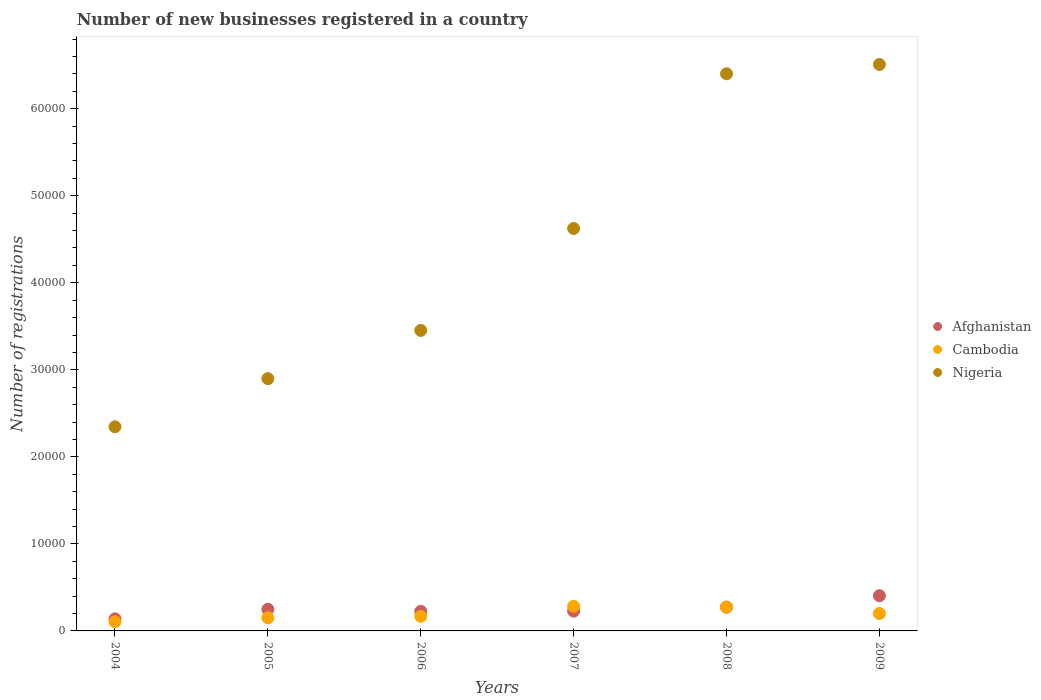What is the number of new businesses registered in Cambodia in 2004?
Your answer should be very brief. 1049. Across all years, what is the maximum number of new businesses registered in Nigeria?
Provide a succinct answer. 6.51e+04. Across all years, what is the minimum number of new businesses registered in Cambodia?
Offer a terse response. 1049. In which year was the number of new businesses registered in Nigeria maximum?
Your answer should be very brief. 2009. In which year was the number of new businesses registered in Afghanistan minimum?
Your response must be concise. 2004. What is the total number of new businesses registered in Cambodia in the graph?
Your answer should be very brief. 1.18e+04. What is the difference between the number of new businesses registered in Nigeria in 2004 and that in 2006?
Keep it short and to the point. -1.11e+04. What is the difference between the number of new businesses registered in Cambodia in 2006 and the number of new businesses registered in Afghanistan in 2007?
Your answer should be very brief. -606. What is the average number of new businesses registered in Afghanistan per year?
Provide a succinct answer. 2527.5. In the year 2004, what is the difference between the number of new businesses registered in Nigeria and number of new businesses registered in Afghanistan?
Offer a terse response. 2.21e+04. In how many years, is the number of new businesses registered in Nigeria greater than 28000?
Your answer should be very brief. 5. What is the ratio of the number of new businesses registered in Cambodia in 2006 to that in 2009?
Your answer should be very brief. 0.83. Is the number of new businesses registered in Afghanistan in 2007 less than that in 2009?
Your response must be concise. Yes. Is the difference between the number of new businesses registered in Nigeria in 2004 and 2008 greater than the difference between the number of new businesses registered in Afghanistan in 2004 and 2008?
Keep it short and to the point. No. What is the difference between the highest and the second highest number of new businesses registered in Nigeria?
Provide a short and direct response. 1072. What is the difference between the highest and the lowest number of new businesses registered in Afghanistan?
Keep it short and to the point. 2655. Does the number of new businesses registered in Afghanistan monotonically increase over the years?
Make the answer very short. No. Is the number of new businesses registered in Afghanistan strictly greater than the number of new businesses registered in Cambodia over the years?
Your answer should be very brief. No. How many dotlines are there?
Ensure brevity in your answer.  3. Are the values on the major ticks of Y-axis written in scientific E-notation?
Keep it short and to the point. No. Does the graph contain any zero values?
Your answer should be compact. No. Where does the legend appear in the graph?
Provide a succinct answer. Center right. How are the legend labels stacked?
Provide a succinct answer. Vertical. What is the title of the graph?
Offer a very short reply. Number of new businesses registered in a country. What is the label or title of the Y-axis?
Keep it short and to the point. Number of registrations. What is the Number of registrations of Afghanistan in 2004?
Provide a succinct answer. 1388. What is the Number of registrations of Cambodia in 2004?
Offer a terse response. 1049. What is the Number of registrations in Nigeria in 2004?
Your answer should be very brief. 2.35e+04. What is the Number of registrations in Afghanistan in 2005?
Give a very brief answer. 2486. What is the Number of registrations of Cambodia in 2005?
Ensure brevity in your answer.  1509. What is the Number of registrations in Nigeria in 2005?
Ensure brevity in your answer.  2.90e+04. What is the Number of registrations of Afghanistan in 2006?
Offer a terse response. 2252. What is the Number of registrations in Cambodia in 2006?
Provide a short and direct response. 1670. What is the Number of registrations of Nigeria in 2006?
Your answer should be very brief. 3.45e+04. What is the Number of registrations in Afghanistan in 2007?
Provide a short and direct response. 2276. What is the Number of registrations of Cambodia in 2007?
Provide a succinct answer. 2826. What is the Number of registrations of Nigeria in 2007?
Ensure brevity in your answer.  4.62e+04. What is the Number of registrations in Afghanistan in 2008?
Make the answer very short. 2720. What is the Number of registrations of Cambodia in 2008?
Offer a terse response. 2744. What is the Number of registrations of Nigeria in 2008?
Your answer should be compact. 6.40e+04. What is the Number of registrations of Afghanistan in 2009?
Offer a very short reply. 4043. What is the Number of registrations in Cambodia in 2009?
Make the answer very short. 2003. What is the Number of registrations in Nigeria in 2009?
Provide a succinct answer. 6.51e+04. Across all years, what is the maximum Number of registrations of Afghanistan?
Give a very brief answer. 4043. Across all years, what is the maximum Number of registrations of Cambodia?
Your response must be concise. 2826. Across all years, what is the maximum Number of registrations of Nigeria?
Provide a succinct answer. 6.51e+04. Across all years, what is the minimum Number of registrations in Afghanistan?
Ensure brevity in your answer.  1388. Across all years, what is the minimum Number of registrations of Cambodia?
Offer a terse response. 1049. Across all years, what is the minimum Number of registrations in Nigeria?
Give a very brief answer. 2.35e+04. What is the total Number of registrations of Afghanistan in the graph?
Your answer should be very brief. 1.52e+04. What is the total Number of registrations of Cambodia in the graph?
Keep it short and to the point. 1.18e+04. What is the total Number of registrations of Nigeria in the graph?
Offer a very short reply. 2.62e+05. What is the difference between the Number of registrations in Afghanistan in 2004 and that in 2005?
Give a very brief answer. -1098. What is the difference between the Number of registrations in Cambodia in 2004 and that in 2005?
Your answer should be compact. -460. What is the difference between the Number of registrations in Nigeria in 2004 and that in 2005?
Your answer should be compact. -5531. What is the difference between the Number of registrations of Afghanistan in 2004 and that in 2006?
Your answer should be compact. -864. What is the difference between the Number of registrations in Cambodia in 2004 and that in 2006?
Offer a terse response. -621. What is the difference between the Number of registrations in Nigeria in 2004 and that in 2006?
Offer a very short reply. -1.11e+04. What is the difference between the Number of registrations of Afghanistan in 2004 and that in 2007?
Keep it short and to the point. -888. What is the difference between the Number of registrations of Cambodia in 2004 and that in 2007?
Give a very brief answer. -1777. What is the difference between the Number of registrations of Nigeria in 2004 and that in 2007?
Offer a terse response. -2.28e+04. What is the difference between the Number of registrations of Afghanistan in 2004 and that in 2008?
Provide a succinct answer. -1332. What is the difference between the Number of registrations in Cambodia in 2004 and that in 2008?
Offer a terse response. -1695. What is the difference between the Number of registrations of Nigeria in 2004 and that in 2008?
Make the answer very short. -4.06e+04. What is the difference between the Number of registrations in Afghanistan in 2004 and that in 2009?
Ensure brevity in your answer.  -2655. What is the difference between the Number of registrations in Cambodia in 2004 and that in 2009?
Your response must be concise. -954. What is the difference between the Number of registrations of Nigeria in 2004 and that in 2009?
Offer a terse response. -4.16e+04. What is the difference between the Number of registrations in Afghanistan in 2005 and that in 2006?
Provide a short and direct response. 234. What is the difference between the Number of registrations in Cambodia in 2005 and that in 2006?
Keep it short and to the point. -161. What is the difference between the Number of registrations in Nigeria in 2005 and that in 2006?
Offer a terse response. -5543. What is the difference between the Number of registrations in Afghanistan in 2005 and that in 2007?
Give a very brief answer. 210. What is the difference between the Number of registrations of Cambodia in 2005 and that in 2007?
Provide a succinct answer. -1317. What is the difference between the Number of registrations in Nigeria in 2005 and that in 2007?
Your answer should be compact. -1.73e+04. What is the difference between the Number of registrations of Afghanistan in 2005 and that in 2008?
Your answer should be very brief. -234. What is the difference between the Number of registrations in Cambodia in 2005 and that in 2008?
Your answer should be very brief. -1235. What is the difference between the Number of registrations in Nigeria in 2005 and that in 2008?
Make the answer very short. -3.50e+04. What is the difference between the Number of registrations of Afghanistan in 2005 and that in 2009?
Offer a terse response. -1557. What is the difference between the Number of registrations in Cambodia in 2005 and that in 2009?
Offer a very short reply. -494. What is the difference between the Number of registrations in Nigeria in 2005 and that in 2009?
Give a very brief answer. -3.61e+04. What is the difference between the Number of registrations in Cambodia in 2006 and that in 2007?
Ensure brevity in your answer.  -1156. What is the difference between the Number of registrations of Nigeria in 2006 and that in 2007?
Make the answer very short. -1.17e+04. What is the difference between the Number of registrations in Afghanistan in 2006 and that in 2008?
Ensure brevity in your answer.  -468. What is the difference between the Number of registrations in Cambodia in 2006 and that in 2008?
Your answer should be very brief. -1074. What is the difference between the Number of registrations in Nigeria in 2006 and that in 2008?
Your answer should be very brief. -2.95e+04. What is the difference between the Number of registrations of Afghanistan in 2006 and that in 2009?
Your answer should be very brief. -1791. What is the difference between the Number of registrations of Cambodia in 2006 and that in 2009?
Ensure brevity in your answer.  -333. What is the difference between the Number of registrations of Nigeria in 2006 and that in 2009?
Keep it short and to the point. -3.06e+04. What is the difference between the Number of registrations of Afghanistan in 2007 and that in 2008?
Offer a terse response. -444. What is the difference between the Number of registrations in Nigeria in 2007 and that in 2008?
Provide a succinct answer. -1.78e+04. What is the difference between the Number of registrations of Afghanistan in 2007 and that in 2009?
Make the answer very short. -1767. What is the difference between the Number of registrations of Cambodia in 2007 and that in 2009?
Your answer should be very brief. 823. What is the difference between the Number of registrations of Nigeria in 2007 and that in 2009?
Make the answer very short. -1.88e+04. What is the difference between the Number of registrations of Afghanistan in 2008 and that in 2009?
Make the answer very short. -1323. What is the difference between the Number of registrations in Cambodia in 2008 and that in 2009?
Give a very brief answer. 741. What is the difference between the Number of registrations in Nigeria in 2008 and that in 2009?
Offer a terse response. -1072. What is the difference between the Number of registrations in Afghanistan in 2004 and the Number of registrations in Cambodia in 2005?
Make the answer very short. -121. What is the difference between the Number of registrations in Afghanistan in 2004 and the Number of registrations in Nigeria in 2005?
Ensure brevity in your answer.  -2.76e+04. What is the difference between the Number of registrations of Cambodia in 2004 and the Number of registrations of Nigeria in 2005?
Your answer should be compact. -2.79e+04. What is the difference between the Number of registrations of Afghanistan in 2004 and the Number of registrations of Cambodia in 2006?
Offer a terse response. -282. What is the difference between the Number of registrations of Afghanistan in 2004 and the Number of registrations of Nigeria in 2006?
Make the answer very short. -3.31e+04. What is the difference between the Number of registrations in Cambodia in 2004 and the Number of registrations in Nigeria in 2006?
Make the answer very short. -3.35e+04. What is the difference between the Number of registrations of Afghanistan in 2004 and the Number of registrations of Cambodia in 2007?
Provide a short and direct response. -1438. What is the difference between the Number of registrations in Afghanistan in 2004 and the Number of registrations in Nigeria in 2007?
Provide a succinct answer. -4.49e+04. What is the difference between the Number of registrations of Cambodia in 2004 and the Number of registrations of Nigeria in 2007?
Provide a succinct answer. -4.52e+04. What is the difference between the Number of registrations in Afghanistan in 2004 and the Number of registrations in Cambodia in 2008?
Offer a very short reply. -1356. What is the difference between the Number of registrations of Afghanistan in 2004 and the Number of registrations of Nigeria in 2008?
Provide a short and direct response. -6.26e+04. What is the difference between the Number of registrations in Cambodia in 2004 and the Number of registrations in Nigeria in 2008?
Your answer should be compact. -6.30e+04. What is the difference between the Number of registrations in Afghanistan in 2004 and the Number of registrations in Cambodia in 2009?
Offer a very short reply. -615. What is the difference between the Number of registrations in Afghanistan in 2004 and the Number of registrations in Nigeria in 2009?
Your response must be concise. -6.37e+04. What is the difference between the Number of registrations in Cambodia in 2004 and the Number of registrations in Nigeria in 2009?
Provide a short and direct response. -6.40e+04. What is the difference between the Number of registrations in Afghanistan in 2005 and the Number of registrations in Cambodia in 2006?
Ensure brevity in your answer.  816. What is the difference between the Number of registrations in Afghanistan in 2005 and the Number of registrations in Nigeria in 2006?
Your answer should be very brief. -3.20e+04. What is the difference between the Number of registrations in Cambodia in 2005 and the Number of registrations in Nigeria in 2006?
Offer a terse response. -3.30e+04. What is the difference between the Number of registrations of Afghanistan in 2005 and the Number of registrations of Cambodia in 2007?
Provide a short and direct response. -340. What is the difference between the Number of registrations in Afghanistan in 2005 and the Number of registrations in Nigeria in 2007?
Give a very brief answer. -4.38e+04. What is the difference between the Number of registrations of Cambodia in 2005 and the Number of registrations of Nigeria in 2007?
Your response must be concise. -4.47e+04. What is the difference between the Number of registrations of Afghanistan in 2005 and the Number of registrations of Cambodia in 2008?
Make the answer very short. -258. What is the difference between the Number of registrations in Afghanistan in 2005 and the Number of registrations in Nigeria in 2008?
Your response must be concise. -6.15e+04. What is the difference between the Number of registrations in Cambodia in 2005 and the Number of registrations in Nigeria in 2008?
Provide a short and direct response. -6.25e+04. What is the difference between the Number of registrations in Afghanistan in 2005 and the Number of registrations in Cambodia in 2009?
Your response must be concise. 483. What is the difference between the Number of registrations of Afghanistan in 2005 and the Number of registrations of Nigeria in 2009?
Your answer should be very brief. -6.26e+04. What is the difference between the Number of registrations in Cambodia in 2005 and the Number of registrations in Nigeria in 2009?
Offer a terse response. -6.36e+04. What is the difference between the Number of registrations in Afghanistan in 2006 and the Number of registrations in Cambodia in 2007?
Your response must be concise. -574. What is the difference between the Number of registrations in Afghanistan in 2006 and the Number of registrations in Nigeria in 2007?
Offer a very short reply. -4.40e+04. What is the difference between the Number of registrations of Cambodia in 2006 and the Number of registrations of Nigeria in 2007?
Your answer should be compact. -4.46e+04. What is the difference between the Number of registrations in Afghanistan in 2006 and the Number of registrations in Cambodia in 2008?
Ensure brevity in your answer.  -492. What is the difference between the Number of registrations of Afghanistan in 2006 and the Number of registrations of Nigeria in 2008?
Provide a short and direct response. -6.18e+04. What is the difference between the Number of registrations in Cambodia in 2006 and the Number of registrations in Nigeria in 2008?
Provide a succinct answer. -6.23e+04. What is the difference between the Number of registrations of Afghanistan in 2006 and the Number of registrations of Cambodia in 2009?
Offer a very short reply. 249. What is the difference between the Number of registrations in Afghanistan in 2006 and the Number of registrations in Nigeria in 2009?
Make the answer very short. -6.28e+04. What is the difference between the Number of registrations of Cambodia in 2006 and the Number of registrations of Nigeria in 2009?
Provide a short and direct response. -6.34e+04. What is the difference between the Number of registrations of Afghanistan in 2007 and the Number of registrations of Cambodia in 2008?
Provide a short and direct response. -468. What is the difference between the Number of registrations of Afghanistan in 2007 and the Number of registrations of Nigeria in 2008?
Your answer should be compact. -6.17e+04. What is the difference between the Number of registrations in Cambodia in 2007 and the Number of registrations in Nigeria in 2008?
Your response must be concise. -6.12e+04. What is the difference between the Number of registrations in Afghanistan in 2007 and the Number of registrations in Cambodia in 2009?
Your response must be concise. 273. What is the difference between the Number of registrations of Afghanistan in 2007 and the Number of registrations of Nigeria in 2009?
Ensure brevity in your answer.  -6.28e+04. What is the difference between the Number of registrations of Cambodia in 2007 and the Number of registrations of Nigeria in 2009?
Provide a succinct answer. -6.23e+04. What is the difference between the Number of registrations in Afghanistan in 2008 and the Number of registrations in Cambodia in 2009?
Offer a terse response. 717. What is the difference between the Number of registrations in Afghanistan in 2008 and the Number of registrations in Nigeria in 2009?
Make the answer very short. -6.24e+04. What is the difference between the Number of registrations of Cambodia in 2008 and the Number of registrations of Nigeria in 2009?
Your answer should be very brief. -6.23e+04. What is the average Number of registrations of Afghanistan per year?
Ensure brevity in your answer.  2527.5. What is the average Number of registrations in Cambodia per year?
Your answer should be very brief. 1966.83. What is the average Number of registrations of Nigeria per year?
Provide a short and direct response. 4.37e+04. In the year 2004, what is the difference between the Number of registrations in Afghanistan and Number of registrations in Cambodia?
Your response must be concise. 339. In the year 2004, what is the difference between the Number of registrations in Afghanistan and Number of registrations in Nigeria?
Provide a short and direct response. -2.21e+04. In the year 2004, what is the difference between the Number of registrations in Cambodia and Number of registrations in Nigeria?
Your response must be concise. -2.24e+04. In the year 2005, what is the difference between the Number of registrations of Afghanistan and Number of registrations of Cambodia?
Provide a succinct answer. 977. In the year 2005, what is the difference between the Number of registrations in Afghanistan and Number of registrations in Nigeria?
Give a very brief answer. -2.65e+04. In the year 2005, what is the difference between the Number of registrations of Cambodia and Number of registrations of Nigeria?
Your answer should be very brief. -2.75e+04. In the year 2006, what is the difference between the Number of registrations of Afghanistan and Number of registrations of Cambodia?
Your answer should be very brief. 582. In the year 2006, what is the difference between the Number of registrations in Afghanistan and Number of registrations in Nigeria?
Ensure brevity in your answer.  -3.23e+04. In the year 2006, what is the difference between the Number of registrations of Cambodia and Number of registrations of Nigeria?
Your answer should be very brief. -3.29e+04. In the year 2007, what is the difference between the Number of registrations of Afghanistan and Number of registrations of Cambodia?
Your response must be concise. -550. In the year 2007, what is the difference between the Number of registrations of Afghanistan and Number of registrations of Nigeria?
Offer a very short reply. -4.40e+04. In the year 2007, what is the difference between the Number of registrations of Cambodia and Number of registrations of Nigeria?
Give a very brief answer. -4.34e+04. In the year 2008, what is the difference between the Number of registrations in Afghanistan and Number of registrations in Nigeria?
Give a very brief answer. -6.13e+04. In the year 2008, what is the difference between the Number of registrations of Cambodia and Number of registrations of Nigeria?
Give a very brief answer. -6.13e+04. In the year 2009, what is the difference between the Number of registrations of Afghanistan and Number of registrations of Cambodia?
Your response must be concise. 2040. In the year 2009, what is the difference between the Number of registrations of Afghanistan and Number of registrations of Nigeria?
Your answer should be compact. -6.10e+04. In the year 2009, what is the difference between the Number of registrations in Cambodia and Number of registrations in Nigeria?
Your answer should be compact. -6.31e+04. What is the ratio of the Number of registrations of Afghanistan in 2004 to that in 2005?
Give a very brief answer. 0.56. What is the ratio of the Number of registrations in Cambodia in 2004 to that in 2005?
Offer a very short reply. 0.7. What is the ratio of the Number of registrations of Nigeria in 2004 to that in 2005?
Offer a terse response. 0.81. What is the ratio of the Number of registrations in Afghanistan in 2004 to that in 2006?
Offer a very short reply. 0.62. What is the ratio of the Number of registrations of Cambodia in 2004 to that in 2006?
Offer a very short reply. 0.63. What is the ratio of the Number of registrations in Nigeria in 2004 to that in 2006?
Ensure brevity in your answer.  0.68. What is the ratio of the Number of registrations in Afghanistan in 2004 to that in 2007?
Ensure brevity in your answer.  0.61. What is the ratio of the Number of registrations of Cambodia in 2004 to that in 2007?
Your answer should be very brief. 0.37. What is the ratio of the Number of registrations in Nigeria in 2004 to that in 2007?
Ensure brevity in your answer.  0.51. What is the ratio of the Number of registrations of Afghanistan in 2004 to that in 2008?
Your response must be concise. 0.51. What is the ratio of the Number of registrations of Cambodia in 2004 to that in 2008?
Your response must be concise. 0.38. What is the ratio of the Number of registrations in Nigeria in 2004 to that in 2008?
Your response must be concise. 0.37. What is the ratio of the Number of registrations in Afghanistan in 2004 to that in 2009?
Offer a terse response. 0.34. What is the ratio of the Number of registrations in Cambodia in 2004 to that in 2009?
Your answer should be compact. 0.52. What is the ratio of the Number of registrations of Nigeria in 2004 to that in 2009?
Your response must be concise. 0.36. What is the ratio of the Number of registrations of Afghanistan in 2005 to that in 2006?
Keep it short and to the point. 1.1. What is the ratio of the Number of registrations in Cambodia in 2005 to that in 2006?
Provide a short and direct response. 0.9. What is the ratio of the Number of registrations in Nigeria in 2005 to that in 2006?
Give a very brief answer. 0.84. What is the ratio of the Number of registrations of Afghanistan in 2005 to that in 2007?
Provide a short and direct response. 1.09. What is the ratio of the Number of registrations in Cambodia in 2005 to that in 2007?
Provide a short and direct response. 0.53. What is the ratio of the Number of registrations in Nigeria in 2005 to that in 2007?
Your response must be concise. 0.63. What is the ratio of the Number of registrations of Afghanistan in 2005 to that in 2008?
Give a very brief answer. 0.91. What is the ratio of the Number of registrations of Cambodia in 2005 to that in 2008?
Make the answer very short. 0.55. What is the ratio of the Number of registrations in Nigeria in 2005 to that in 2008?
Give a very brief answer. 0.45. What is the ratio of the Number of registrations in Afghanistan in 2005 to that in 2009?
Make the answer very short. 0.61. What is the ratio of the Number of registrations in Cambodia in 2005 to that in 2009?
Ensure brevity in your answer.  0.75. What is the ratio of the Number of registrations in Nigeria in 2005 to that in 2009?
Give a very brief answer. 0.45. What is the ratio of the Number of registrations in Afghanistan in 2006 to that in 2007?
Offer a very short reply. 0.99. What is the ratio of the Number of registrations in Cambodia in 2006 to that in 2007?
Your answer should be very brief. 0.59. What is the ratio of the Number of registrations in Nigeria in 2006 to that in 2007?
Your answer should be compact. 0.75. What is the ratio of the Number of registrations in Afghanistan in 2006 to that in 2008?
Your response must be concise. 0.83. What is the ratio of the Number of registrations of Cambodia in 2006 to that in 2008?
Your answer should be compact. 0.61. What is the ratio of the Number of registrations in Nigeria in 2006 to that in 2008?
Make the answer very short. 0.54. What is the ratio of the Number of registrations in Afghanistan in 2006 to that in 2009?
Offer a terse response. 0.56. What is the ratio of the Number of registrations in Cambodia in 2006 to that in 2009?
Your answer should be very brief. 0.83. What is the ratio of the Number of registrations of Nigeria in 2006 to that in 2009?
Your answer should be very brief. 0.53. What is the ratio of the Number of registrations in Afghanistan in 2007 to that in 2008?
Provide a short and direct response. 0.84. What is the ratio of the Number of registrations in Cambodia in 2007 to that in 2008?
Your answer should be very brief. 1.03. What is the ratio of the Number of registrations in Nigeria in 2007 to that in 2008?
Offer a very short reply. 0.72. What is the ratio of the Number of registrations of Afghanistan in 2007 to that in 2009?
Your answer should be compact. 0.56. What is the ratio of the Number of registrations in Cambodia in 2007 to that in 2009?
Offer a very short reply. 1.41. What is the ratio of the Number of registrations of Nigeria in 2007 to that in 2009?
Make the answer very short. 0.71. What is the ratio of the Number of registrations of Afghanistan in 2008 to that in 2009?
Ensure brevity in your answer.  0.67. What is the ratio of the Number of registrations of Cambodia in 2008 to that in 2009?
Make the answer very short. 1.37. What is the ratio of the Number of registrations in Nigeria in 2008 to that in 2009?
Provide a succinct answer. 0.98. What is the difference between the highest and the second highest Number of registrations in Afghanistan?
Offer a very short reply. 1323. What is the difference between the highest and the second highest Number of registrations of Nigeria?
Offer a terse response. 1072. What is the difference between the highest and the lowest Number of registrations of Afghanistan?
Your response must be concise. 2655. What is the difference between the highest and the lowest Number of registrations in Cambodia?
Keep it short and to the point. 1777. What is the difference between the highest and the lowest Number of registrations of Nigeria?
Provide a short and direct response. 4.16e+04. 